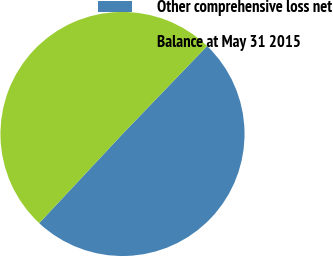<chart> <loc_0><loc_0><loc_500><loc_500><pie_chart><fcel>Other comprehensive loss net<fcel>Balance at May 31 2015<nl><fcel>49.76%<fcel>50.24%<nl></chart> 